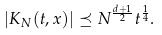Convert formula to latex. <formula><loc_0><loc_0><loc_500><loc_500>| K _ { N } ( t , x ) | \preceq N ^ { \frac { d + 1 } { 2 } } t ^ { \frac { 1 } { 4 } } .</formula> 